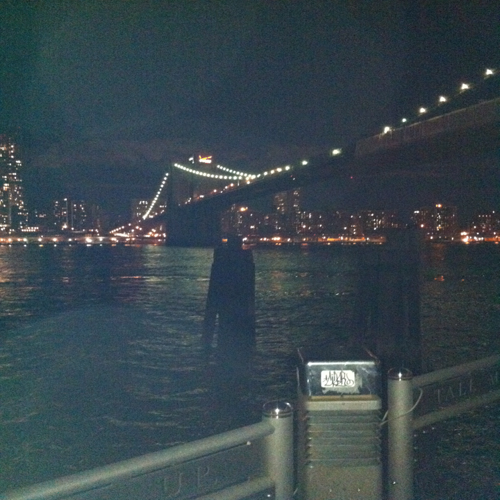What is the overall sharpness of this image?
 High 